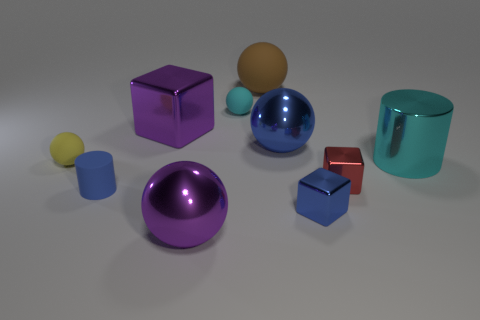Subtract 2 spheres. How many spheres are left? 3 Subtract all blue spheres. How many spheres are left? 4 Subtract all large purple spheres. How many spheres are left? 4 Subtract all gray spheres. Subtract all gray cylinders. How many spheres are left? 5 Subtract all blocks. How many objects are left? 7 Subtract 0 gray cubes. How many objects are left? 10 Subtract all large purple metal balls. Subtract all small shiny cubes. How many objects are left? 7 Add 2 blue objects. How many blue objects are left? 5 Add 6 small shiny objects. How many small shiny objects exist? 8 